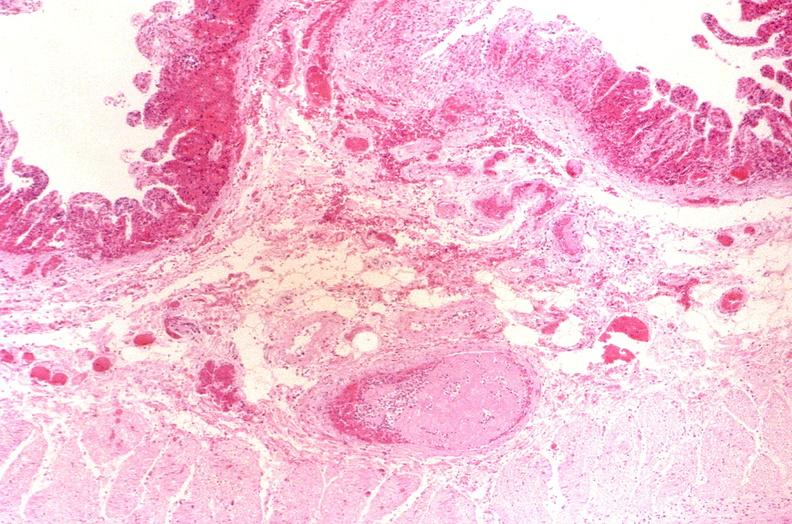does aldehyde fuscin show thrombosed esophageal varices?
Answer the question using a single word or phrase. No 